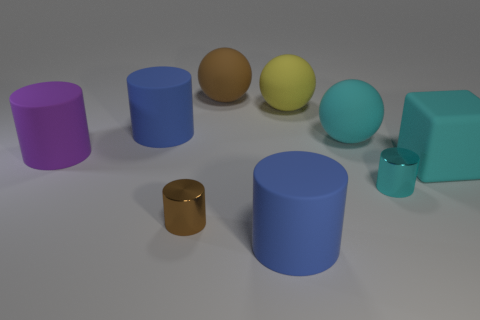Subtract all gray cylinders. Subtract all blue spheres. How many cylinders are left? 5 Add 1 yellow shiny balls. How many objects exist? 10 Subtract all cylinders. How many objects are left? 4 Subtract all tiny brown things. Subtract all cyan objects. How many objects are left? 5 Add 6 brown cylinders. How many brown cylinders are left? 7 Add 6 small red metallic cylinders. How many small red metallic cylinders exist? 6 Subtract 0 green cylinders. How many objects are left? 9 